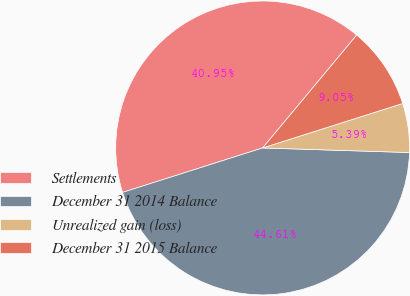Convert chart. <chart><loc_0><loc_0><loc_500><loc_500><pie_chart><fcel>Settlements<fcel>December 31 2014 Balance<fcel>Unrealized gain (loss)<fcel>December 31 2015 Balance<nl><fcel>40.95%<fcel>44.61%<fcel>5.39%<fcel>9.05%<nl></chart> 